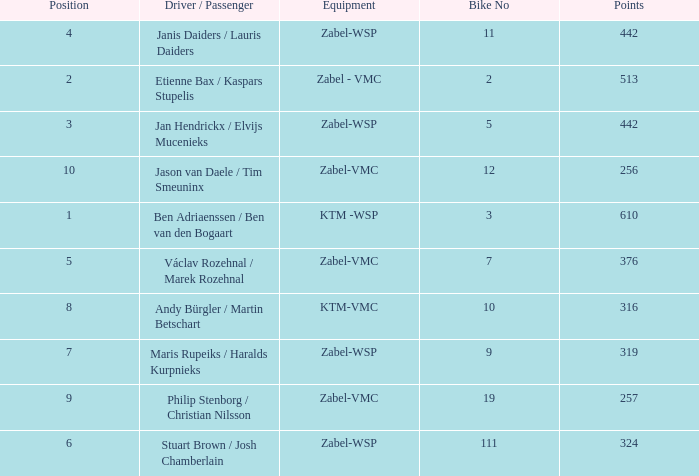What is the Equipment that has a Point bigger than 256, and a Position of 3? Zabel-WSP. 